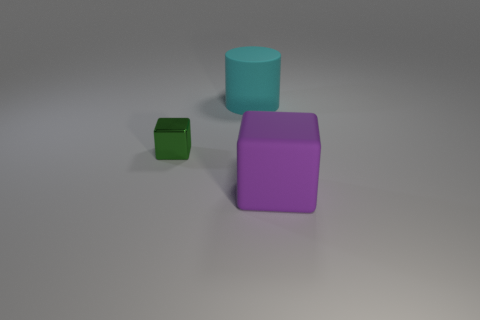Is the shape of the large object behind the large rubber cube the same as  the purple object?
Offer a very short reply. No. What is the color of the small thing?
Your response must be concise. Green. Is there a green metallic cube?
Provide a succinct answer. Yes. What is the size of the purple object that is the same material as the cylinder?
Offer a terse response. Large. What shape is the large matte object that is in front of the matte thing behind the block left of the big purple rubber block?
Your response must be concise. Cube. Is the number of large cyan cylinders that are left of the tiny green cube the same as the number of purple rubber things?
Your answer should be compact. No. Does the small green metal object have the same shape as the large purple object?
Your response must be concise. Yes. How many things are rubber things that are behind the green metallic thing or large purple rubber objects?
Keep it short and to the point. 2. Are there an equal number of objects that are behind the green shiny block and small shiny cubes that are behind the purple block?
Your answer should be compact. Yes. How many other things are the same shape as the big purple matte thing?
Provide a short and direct response. 1. 